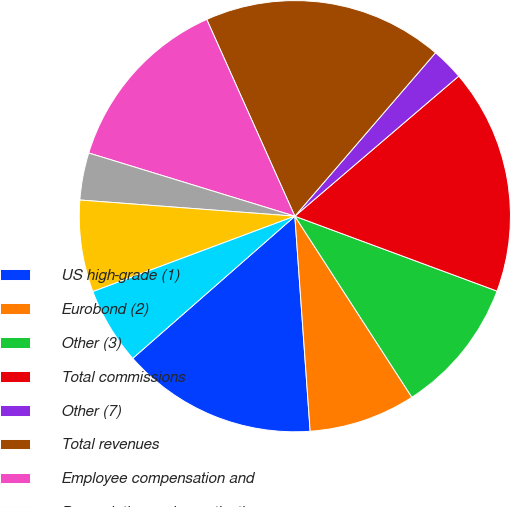Convert chart. <chart><loc_0><loc_0><loc_500><loc_500><pie_chart><fcel>US high-grade (1)<fcel>Eurobond (2)<fcel>Other (3)<fcel>Total commissions<fcel>Other (7)<fcel>Total revenues<fcel>Employee compensation and<fcel>Depreciation and amortization<fcel>Technology and communications<fcel>Professional and consulting<nl><fcel>14.67%<fcel>8.0%<fcel>10.22%<fcel>16.9%<fcel>2.43%<fcel>18.01%<fcel>13.56%<fcel>3.54%<fcel>6.88%<fcel>5.77%<nl></chart> 